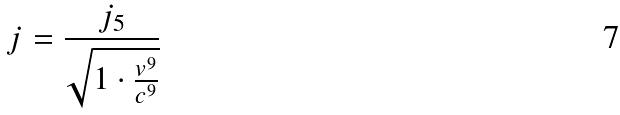<formula> <loc_0><loc_0><loc_500><loc_500>j = \frac { j _ { 5 } } { \sqrt { 1 \cdot \frac { v ^ { 9 } } { c ^ { 9 } } } }</formula> 